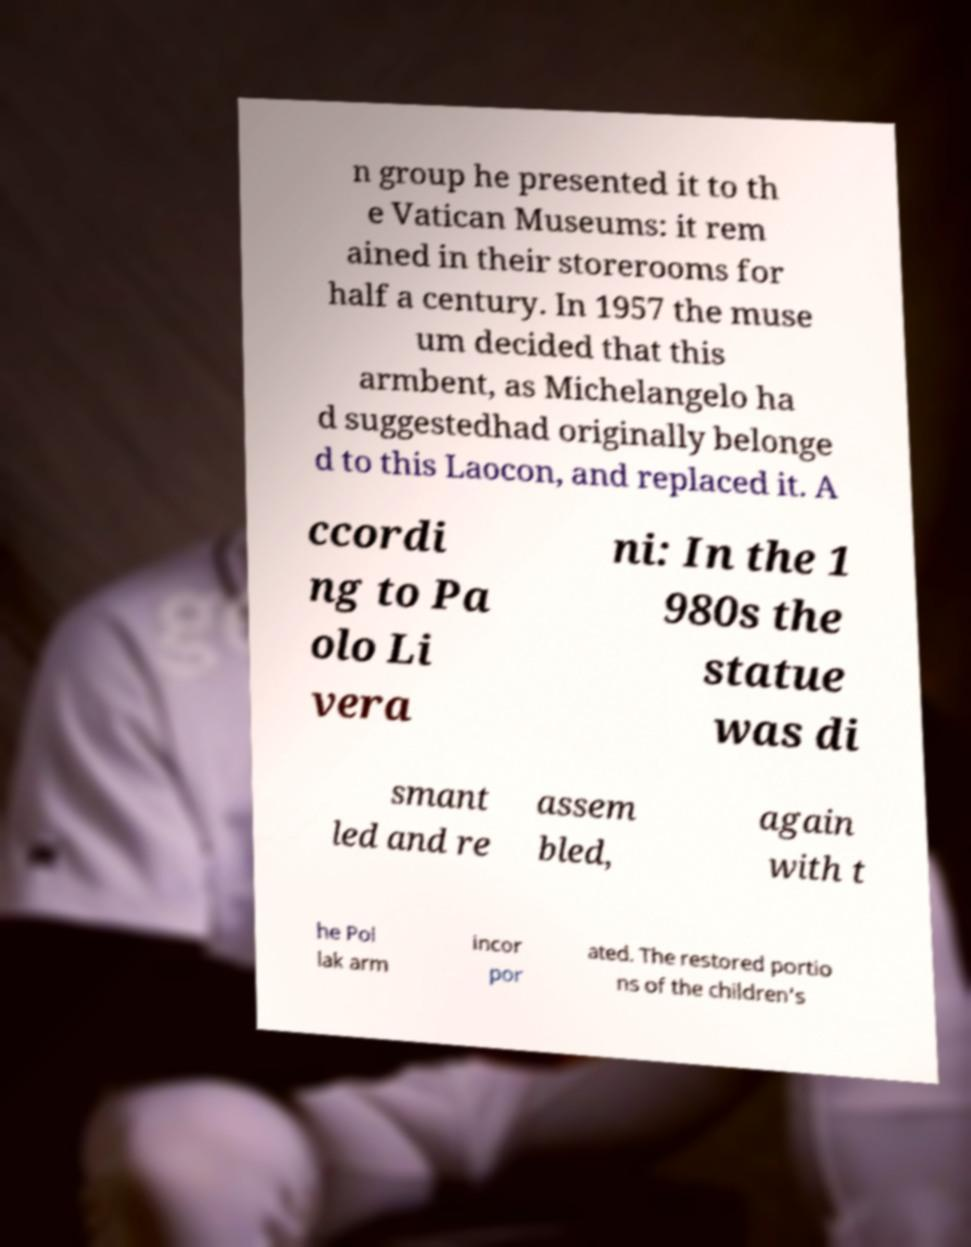I need the written content from this picture converted into text. Can you do that? n group he presented it to th e Vatican Museums: it rem ained in their storerooms for half a century. In 1957 the muse um decided that this armbent, as Michelangelo ha d suggestedhad originally belonge d to this Laocon, and replaced it. A ccordi ng to Pa olo Li vera ni: In the 1 980s the statue was di smant led and re assem bled, again with t he Pol lak arm incor por ated. The restored portio ns of the children's 